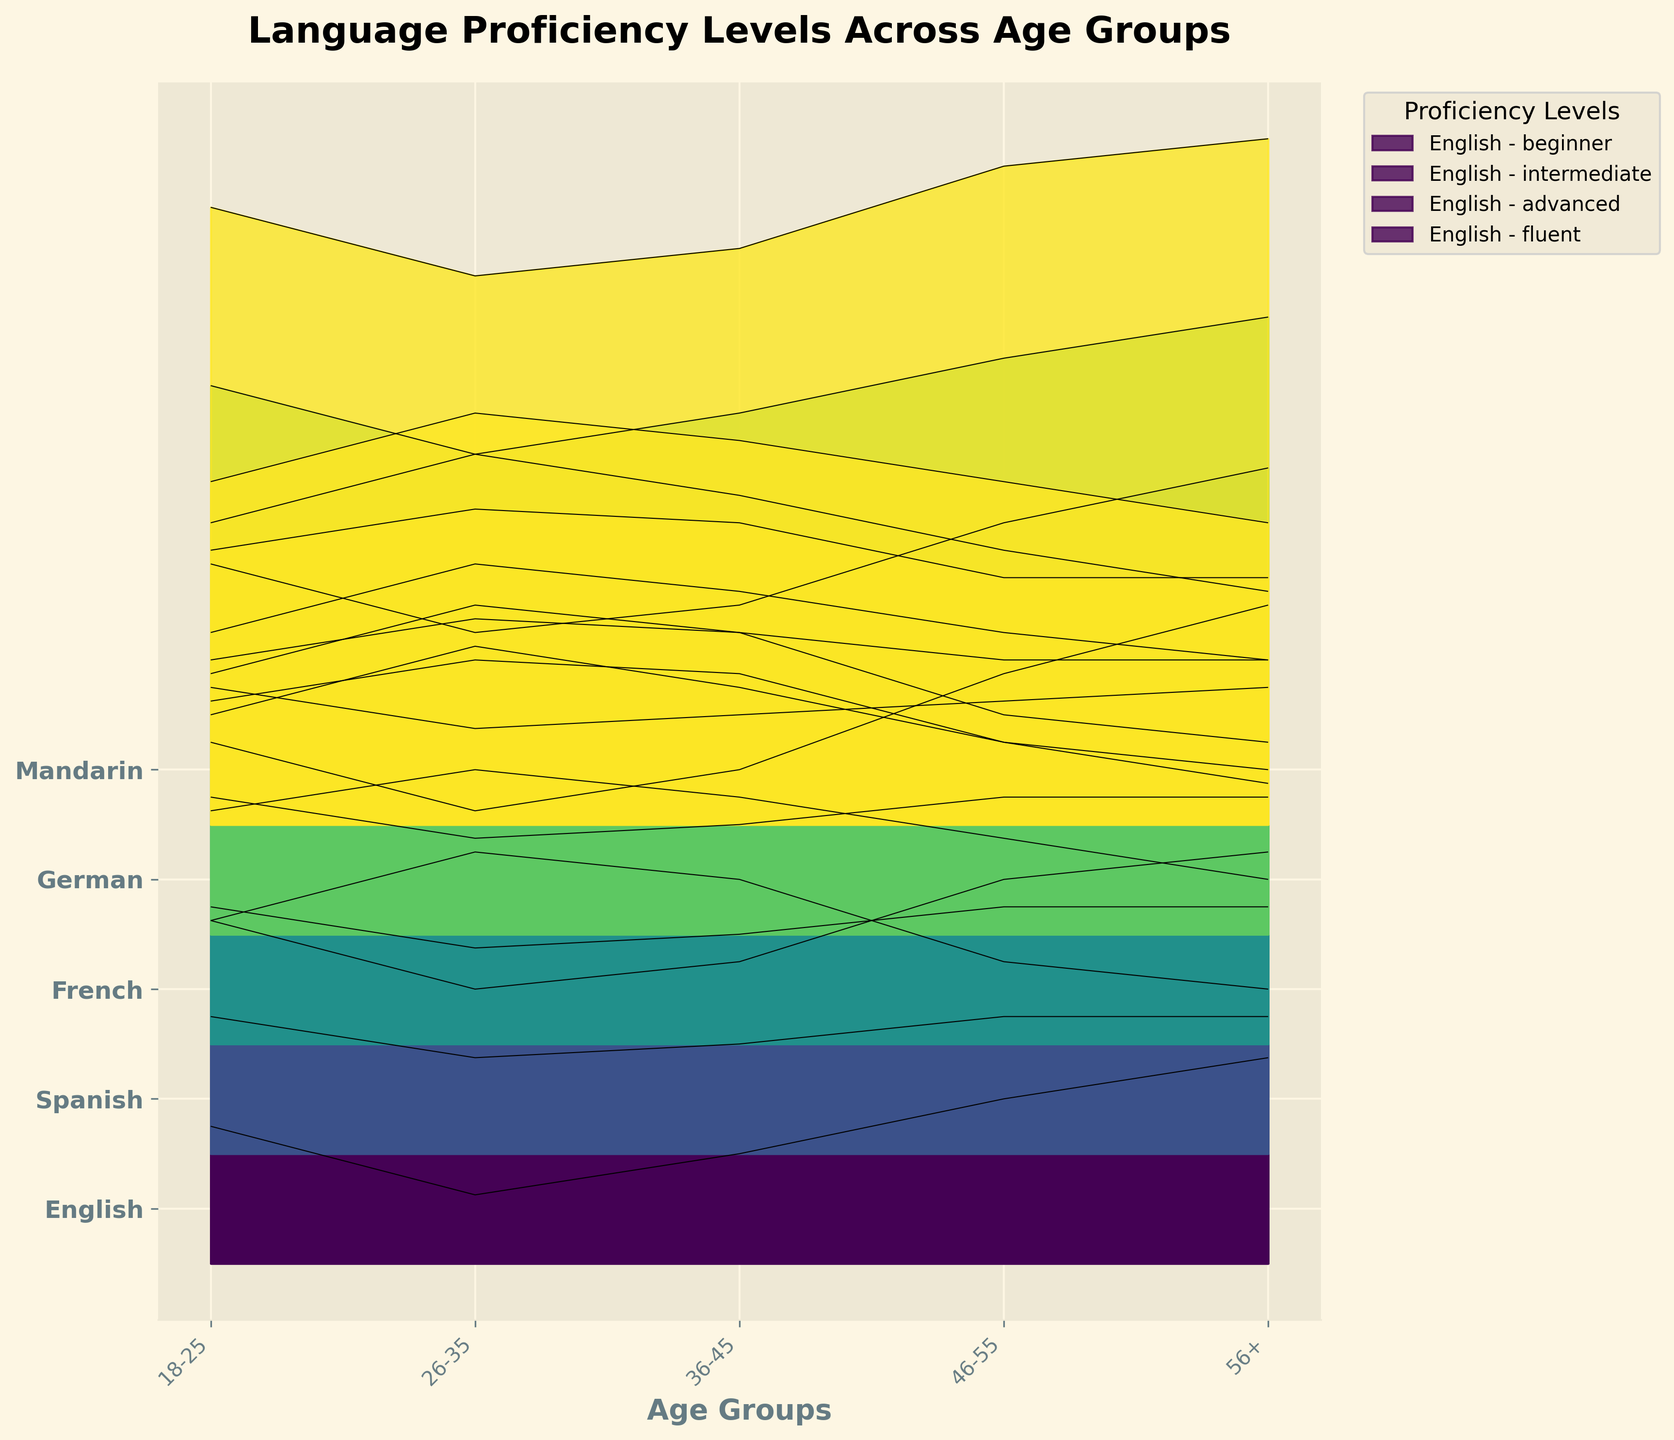What is the title of the figure? The title of the figure is typically placed at the top of the plot. In this case, it should be directly observed from the figure's header.
Answer: Language Proficiency Levels Across Age Groups How many different languages are represented in the plot? By examining the y-axis labels, we can count the number of different languages listed.
Answer: 5 Which language has the highest proficiency level listed as "fluent" for the 26-35 age group? To find this, we need to identify the 26-35 age group and check the "fluent" proficiency level for each language. For English, it's 30; for Spanish, it's 7; for French, it's 7; for German, it's 7; for Mandarin, it's 7. So, English has the highest value.
Answer: English Between which two age groups does Spanish show the biggest decrease in the 'beginner' level? We need to compare the 'beginner' levels for all age groups for Spanish. The values are 30, 25, 28, 35, 40. The biggest increase is between 18-25 to 26-35 (5).
Answer: 18-25 to 26-35 Among all age groups, which age group has the highest 'intermediate' proficiency level for Mandarin? By examining the shaded areas and the heights of the regions labeled as 'intermediate' for Mandarin, we check the age groups. The 'intermediate' proficiency levels for Mandarin are 25, 30, 28, 25, 22. So, the highest is at age group 26-35.
Answer: 26-35 Which language shows the highest level of proficiency for 'advanced' users in the 46-55 age group? By comparing the heights of the 'advanced' sections for the 46-55 age group across all languages, the values are: English (38), Spanish (23), French (22), German (20), Mandarin (18). English has the highest value.
Answer: English What trend do we see in the 'beginner' proficiency level for French as the age groups progress from 18-25 to 56+? Analyzing the values, we observe that the 'beginner' levels for French across the age groups are: 35, 30, 32, 38, 42. The general trend is an increase in 'beginner' levels with increasing age.
Answer: Increasing For the age group 56+, which language has the smallest proportion of 'fluent' speakers? Check the 'fluent' levels for the 56+ age group across all languages. The values are: English (20), Spanish (10), French (10), German (10), Mandarin (10). All except English are tied for the smallest.
Answer: Spanish, French, German, Mandarin (tie) Which language has a decreasing trend in 'advanced' proficiency with increasing age groups? We need to examine the 'advanced' proficiency trend across the age groups for each language. All values are for English (40, 45, 42, 38, 35), Spanish (25, 28, 26, 23, 20), French (25, 28, 27, 22, 20), German (20, 23, 22, 20, 18), Mandarin (20, 23, 22, 18, 18). The trend for all the languages show a decrease or mixed trend but considering clear decreasing trend: Mandarin shows decrease at first.
Answer: Mandarin In which age group does German have the highest 'beginner' proficiency level? By examining the 'beginner' proficiency levels for German across all age groups (40, 35, 38, 42, 45), the highest level is at age group 56+.
Answer: 56+ 